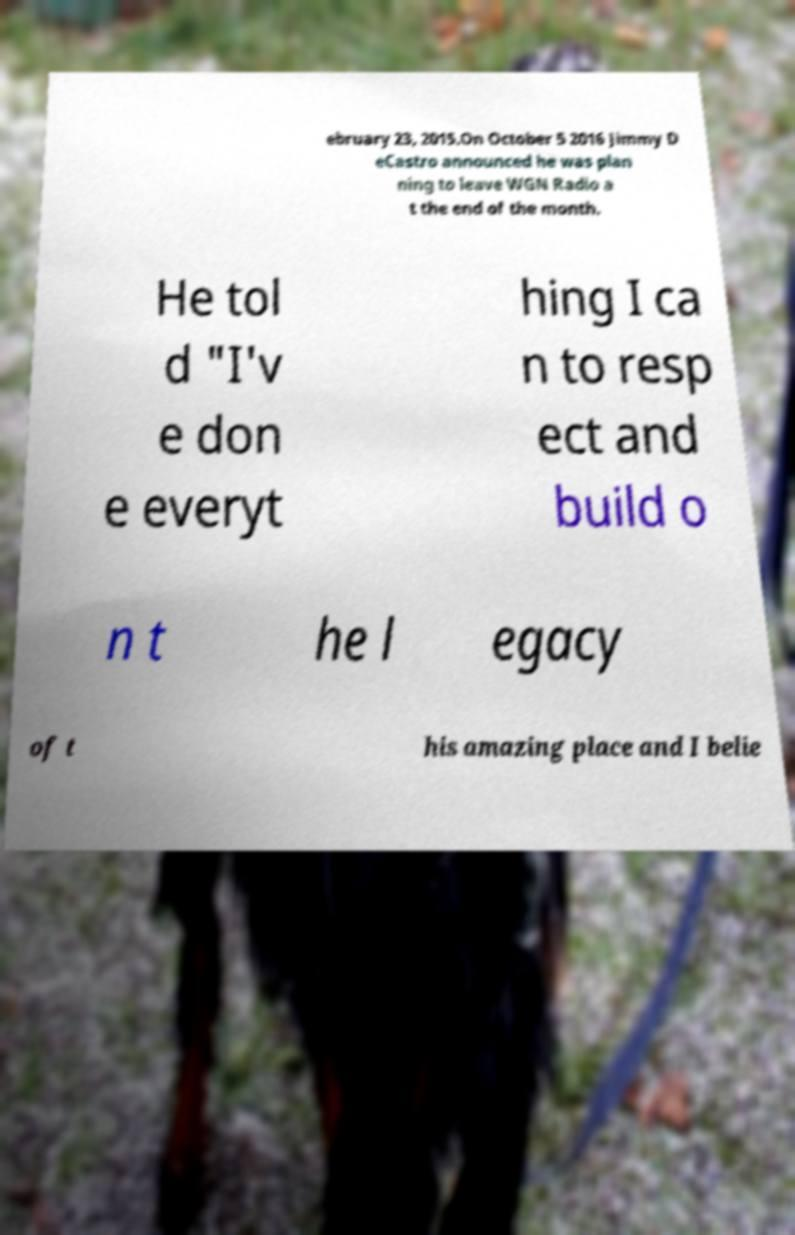For documentation purposes, I need the text within this image transcribed. Could you provide that? ebruary 23, 2015.On October 5 2016 Jimmy D eCastro announced he was plan ning to leave WGN Radio a t the end of the month. He tol d "I'v e don e everyt hing I ca n to resp ect and build o n t he l egacy of t his amazing place and I belie 